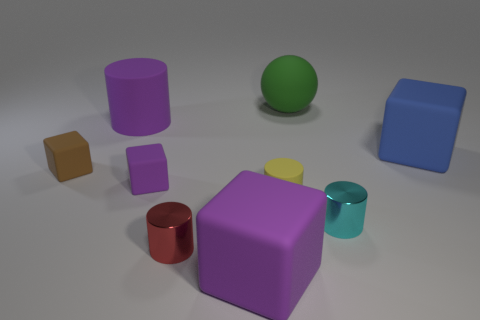There is a small cyan thing that is the same shape as the red thing; what is its material?
Your answer should be very brief. Metal. Do the big cylinder and the tiny object right of the sphere have the same material?
Provide a succinct answer. No. How many objects are either large purple matte objects that are right of the purple cylinder or tiny objects that are right of the large purple matte cube?
Provide a short and direct response. 3. What is the shape of the object that is both left of the green sphere and behind the brown matte cube?
Give a very brief answer. Cylinder. There is a large thing that is in front of the brown cube; what number of brown cubes are in front of it?
Your response must be concise. 0. What number of things are purple matte objects in front of the big blue thing or purple objects?
Ensure brevity in your answer.  3. There is a purple rubber cube that is behind the red cylinder; what is its size?
Keep it short and to the point. Small. What is the tiny red thing made of?
Provide a succinct answer. Metal. There is a large purple object behind the small rubber block that is to the right of the big rubber cylinder; what is its shape?
Provide a succinct answer. Cylinder. How many other objects are there of the same shape as the large green object?
Your answer should be compact. 0. 